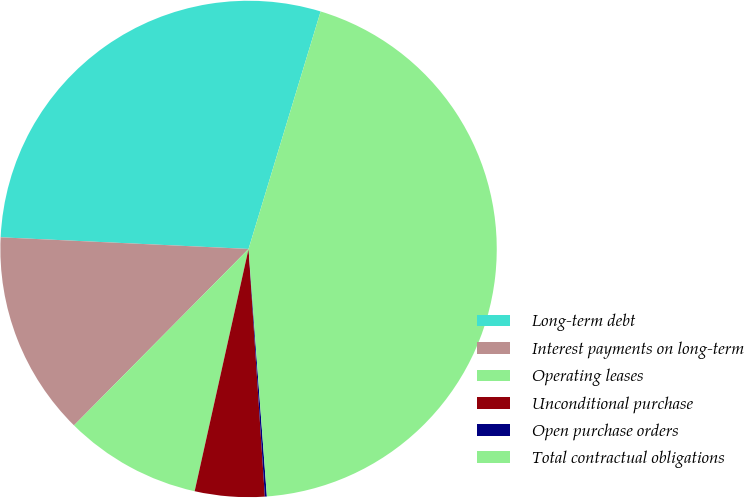<chart> <loc_0><loc_0><loc_500><loc_500><pie_chart><fcel>Long-term debt<fcel>Interest payments on long-term<fcel>Operating leases<fcel>Unconditional purchase<fcel>Open purchase orders<fcel>Total contractual obligations<nl><fcel>28.94%<fcel>13.33%<fcel>8.93%<fcel>4.53%<fcel>0.13%<fcel>44.13%<nl></chart> 